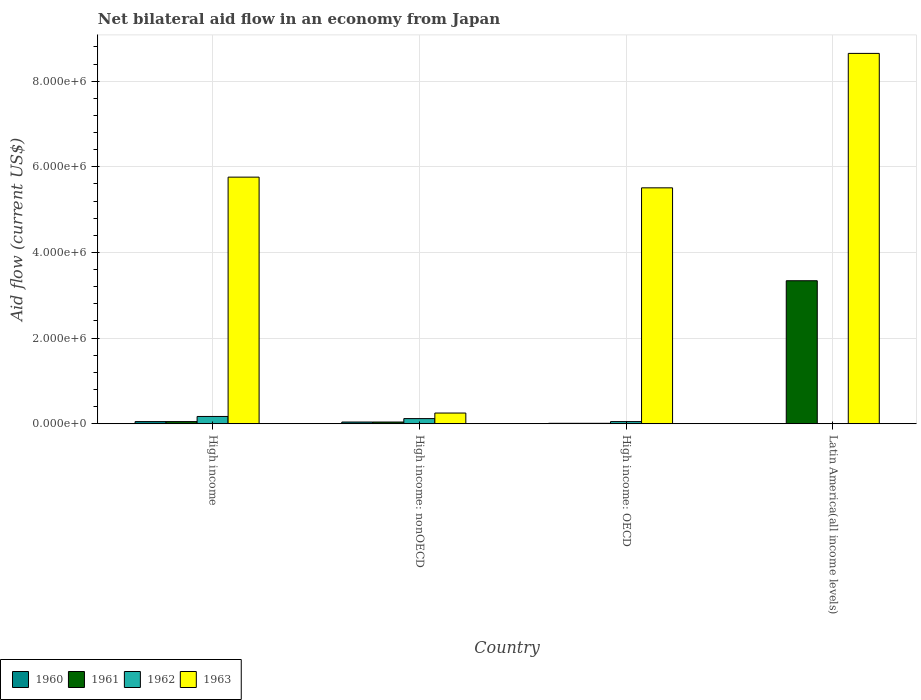How many different coloured bars are there?
Your response must be concise. 4. How many groups of bars are there?
Give a very brief answer. 4. How many bars are there on the 3rd tick from the right?
Make the answer very short. 4. What is the label of the 3rd group of bars from the left?
Give a very brief answer. High income: OECD. Across all countries, what is the maximum net bilateral aid flow in 1963?
Make the answer very short. 8.65e+06. Across all countries, what is the minimum net bilateral aid flow in 1963?
Your answer should be compact. 2.50e+05. In which country was the net bilateral aid flow in 1960 maximum?
Your answer should be compact. High income. What is the difference between the net bilateral aid flow in 1961 in High income: OECD and that in High income: nonOECD?
Provide a short and direct response. -3.00e+04. What is the difference between the net bilateral aid flow in 1963 in High income and the net bilateral aid flow in 1961 in Latin America(all income levels)?
Give a very brief answer. 2.42e+06. What is the average net bilateral aid flow in 1961 per country?
Offer a terse response. 8.60e+05. In how many countries, is the net bilateral aid flow in 1961 greater than 2800000 US$?
Offer a terse response. 1. What is the ratio of the net bilateral aid flow in 1960 in High income to that in High income: nonOECD?
Your answer should be very brief. 1.25. What is the difference between the highest and the second highest net bilateral aid flow in 1963?
Your answer should be compact. 2.89e+06. Is it the case that in every country, the sum of the net bilateral aid flow in 1961 and net bilateral aid flow in 1963 is greater than the net bilateral aid flow in 1960?
Provide a short and direct response. Yes. How many bars are there?
Your response must be concise. 14. What is the difference between two consecutive major ticks on the Y-axis?
Provide a succinct answer. 2.00e+06. Does the graph contain grids?
Offer a terse response. Yes. How are the legend labels stacked?
Provide a succinct answer. Horizontal. What is the title of the graph?
Give a very brief answer. Net bilateral aid flow in an economy from Japan. What is the Aid flow (current US$) in 1961 in High income?
Ensure brevity in your answer.  5.00e+04. What is the Aid flow (current US$) of 1963 in High income?
Offer a very short reply. 5.76e+06. What is the Aid flow (current US$) of 1962 in High income: OECD?
Offer a terse response. 5.00e+04. What is the Aid flow (current US$) of 1963 in High income: OECD?
Make the answer very short. 5.51e+06. What is the Aid flow (current US$) of 1960 in Latin America(all income levels)?
Offer a terse response. 0. What is the Aid flow (current US$) of 1961 in Latin America(all income levels)?
Keep it short and to the point. 3.34e+06. What is the Aid flow (current US$) of 1963 in Latin America(all income levels)?
Your response must be concise. 8.65e+06. Across all countries, what is the maximum Aid flow (current US$) of 1961?
Ensure brevity in your answer.  3.34e+06. Across all countries, what is the maximum Aid flow (current US$) of 1963?
Your answer should be compact. 8.65e+06. Across all countries, what is the minimum Aid flow (current US$) in 1961?
Provide a short and direct response. 10000. Across all countries, what is the minimum Aid flow (current US$) in 1962?
Your response must be concise. 0. What is the total Aid flow (current US$) in 1960 in the graph?
Offer a very short reply. 1.00e+05. What is the total Aid flow (current US$) in 1961 in the graph?
Provide a short and direct response. 3.44e+06. What is the total Aid flow (current US$) of 1963 in the graph?
Offer a terse response. 2.02e+07. What is the difference between the Aid flow (current US$) of 1963 in High income and that in High income: nonOECD?
Offer a terse response. 5.51e+06. What is the difference between the Aid flow (current US$) in 1962 in High income and that in High income: OECD?
Provide a succinct answer. 1.20e+05. What is the difference between the Aid flow (current US$) in 1961 in High income and that in Latin America(all income levels)?
Keep it short and to the point. -3.29e+06. What is the difference between the Aid flow (current US$) of 1963 in High income and that in Latin America(all income levels)?
Your answer should be compact. -2.89e+06. What is the difference between the Aid flow (current US$) in 1961 in High income: nonOECD and that in High income: OECD?
Ensure brevity in your answer.  3.00e+04. What is the difference between the Aid flow (current US$) of 1962 in High income: nonOECD and that in High income: OECD?
Offer a very short reply. 7.00e+04. What is the difference between the Aid flow (current US$) in 1963 in High income: nonOECD and that in High income: OECD?
Make the answer very short. -5.26e+06. What is the difference between the Aid flow (current US$) in 1961 in High income: nonOECD and that in Latin America(all income levels)?
Offer a terse response. -3.30e+06. What is the difference between the Aid flow (current US$) of 1963 in High income: nonOECD and that in Latin America(all income levels)?
Your answer should be compact. -8.40e+06. What is the difference between the Aid flow (current US$) of 1961 in High income: OECD and that in Latin America(all income levels)?
Make the answer very short. -3.33e+06. What is the difference between the Aid flow (current US$) in 1963 in High income: OECD and that in Latin America(all income levels)?
Offer a very short reply. -3.14e+06. What is the difference between the Aid flow (current US$) in 1960 in High income and the Aid flow (current US$) in 1961 in High income: nonOECD?
Provide a succinct answer. 10000. What is the difference between the Aid flow (current US$) of 1962 in High income and the Aid flow (current US$) of 1963 in High income: nonOECD?
Your answer should be very brief. -8.00e+04. What is the difference between the Aid flow (current US$) in 1960 in High income and the Aid flow (current US$) in 1962 in High income: OECD?
Offer a terse response. 0. What is the difference between the Aid flow (current US$) of 1960 in High income and the Aid flow (current US$) of 1963 in High income: OECD?
Your response must be concise. -5.46e+06. What is the difference between the Aid flow (current US$) in 1961 in High income and the Aid flow (current US$) in 1962 in High income: OECD?
Your answer should be compact. 0. What is the difference between the Aid flow (current US$) of 1961 in High income and the Aid flow (current US$) of 1963 in High income: OECD?
Your response must be concise. -5.46e+06. What is the difference between the Aid flow (current US$) of 1962 in High income and the Aid flow (current US$) of 1963 in High income: OECD?
Offer a very short reply. -5.34e+06. What is the difference between the Aid flow (current US$) of 1960 in High income and the Aid flow (current US$) of 1961 in Latin America(all income levels)?
Provide a short and direct response. -3.29e+06. What is the difference between the Aid flow (current US$) of 1960 in High income and the Aid flow (current US$) of 1963 in Latin America(all income levels)?
Your answer should be compact. -8.60e+06. What is the difference between the Aid flow (current US$) of 1961 in High income and the Aid flow (current US$) of 1963 in Latin America(all income levels)?
Give a very brief answer. -8.60e+06. What is the difference between the Aid flow (current US$) in 1962 in High income and the Aid flow (current US$) in 1963 in Latin America(all income levels)?
Offer a very short reply. -8.48e+06. What is the difference between the Aid flow (current US$) in 1960 in High income: nonOECD and the Aid flow (current US$) in 1961 in High income: OECD?
Your answer should be very brief. 3.00e+04. What is the difference between the Aid flow (current US$) of 1960 in High income: nonOECD and the Aid flow (current US$) of 1963 in High income: OECD?
Provide a short and direct response. -5.47e+06. What is the difference between the Aid flow (current US$) of 1961 in High income: nonOECD and the Aid flow (current US$) of 1963 in High income: OECD?
Offer a very short reply. -5.47e+06. What is the difference between the Aid flow (current US$) of 1962 in High income: nonOECD and the Aid flow (current US$) of 1963 in High income: OECD?
Offer a terse response. -5.39e+06. What is the difference between the Aid flow (current US$) in 1960 in High income: nonOECD and the Aid flow (current US$) in 1961 in Latin America(all income levels)?
Your answer should be compact. -3.30e+06. What is the difference between the Aid flow (current US$) in 1960 in High income: nonOECD and the Aid flow (current US$) in 1963 in Latin America(all income levels)?
Ensure brevity in your answer.  -8.61e+06. What is the difference between the Aid flow (current US$) of 1961 in High income: nonOECD and the Aid flow (current US$) of 1963 in Latin America(all income levels)?
Keep it short and to the point. -8.61e+06. What is the difference between the Aid flow (current US$) in 1962 in High income: nonOECD and the Aid flow (current US$) in 1963 in Latin America(all income levels)?
Your answer should be very brief. -8.53e+06. What is the difference between the Aid flow (current US$) in 1960 in High income: OECD and the Aid flow (current US$) in 1961 in Latin America(all income levels)?
Keep it short and to the point. -3.33e+06. What is the difference between the Aid flow (current US$) of 1960 in High income: OECD and the Aid flow (current US$) of 1963 in Latin America(all income levels)?
Provide a short and direct response. -8.64e+06. What is the difference between the Aid flow (current US$) of 1961 in High income: OECD and the Aid flow (current US$) of 1963 in Latin America(all income levels)?
Provide a short and direct response. -8.64e+06. What is the difference between the Aid flow (current US$) of 1962 in High income: OECD and the Aid flow (current US$) of 1963 in Latin America(all income levels)?
Ensure brevity in your answer.  -8.60e+06. What is the average Aid flow (current US$) in 1960 per country?
Provide a short and direct response. 2.50e+04. What is the average Aid flow (current US$) in 1961 per country?
Provide a succinct answer. 8.60e+05. What is the average Aid flow (current US$) of 1962 per country?
Provide a succinct answer. 8.50e+04. What is the average Aid flow (current US$) in 1963 per country?
Ensure brevity in your answer.  5.04e+06. What is the difference between the Aid flow (current US$) of 1960 and Aid flow (current US$) of 1961 in High income?
Your answer should be very brief. 0. What is the difference between the Aid flow (current US$) in 1960 and Aid flow (current US$) in 1962 in High income?
Provide a short and direct response. -1.20e+05. What is the difference between the Aid flow (current US$) of 1960 and Aid flow (current US$) of 1963 in High income?
Make the answer very short. -5.71e+06. What is the difference between the Aid flow (current US$) in 1961 and Aid flow (current US$) in 1963 in High income?
Ensure brevity in your answer.  -5.71e+06. What is the difference between the Aid flow (current US$) of 1962 and Aid flow (current US$) of 1963 in High income?
Your answer should be very brief. -5.59e+06. What is the difference between the Aid flow (current US$) of 1960 and Aid flow (current US$) of 1961 in High income: nonOECD?
Give a very brief answer. 0. What is the difference between the Aid flow (current US$) in 1960 and Aid flow (current US$) in 1962 in High income: nonOECD?
Provide a short and direct response. -8.00e+04. What is the difference between the Aid flow (current US$) in 1961 and Aid flow (current US$) in 1962 in High income: nonOECD?
Your response must be concise. -8.00e+04. What is the difference between the Aid flow (current US$) of 1962 and Aid flow (current US$) of 1963 in High income: nonOECD?
Keep it short and to the point. -1.30e+05. What is the difference between the Aid flow (current US$) of 1960 and Aid flow (current US$) of 1962 in High income: OECD?
Provide a short and direct response. -4.00e+04. What is the difference between the Aid flow (current US$) of 1960 and Aid flow (current US$) of 1963 in High income: OECD?
Your response must be concise. -5.50e+06. What is the difference between the Aid flow (current US$) of 1961 and Aid flow (current US$) of 1963 in High income: OECD?
Your answer should be very brief. -5.50e+06. What is the difference between the Aid flow (current US$) of 1962 and Aid flow (current US$) of 1963 in High income: OECD?
Make the answer very short. -5.46e+06. What is the difference between the Aid flow (current US$) in 1961 and Aid flow (current US$) in 1963 in Latin America(all income levels)?
Make the answer very short. -5.31e+06. What is the ratio of the Aid flow (current US$) of 1960 in High income to that in High income: nonOECD?
Your answer should be very brief. 1.25. What is the ratio of the Aid flow (current US$) in 1961 in High income to that in High income: nonOECD?
Ensure brevity in your answer.  1.25. What is the ratio of the Aid flow (current US$) of 1962 in High income to that in High income: nonOECD?
Your response must be concise. 1.42. What is the ratio of the Aid flow (current US$) in 1963 in High income to that in High income: nonOECD?
Keep it short and to the point. 23.04. What is the ratio of the Aid flow (current US$) in 1960 in High income to that in High income: OECD?
Your answer should be very brief. 5. What is the ratio of the Aid flow (current US$) of 1963 in High income to that in High income: OECD?
Give a very brief answer. 1.05. What is the ratio of the Aid flow (current US$) in 1961 in High income to that in Latin America(all income levels)?
Keep it short and to the point. 0.01. What is the ratio of the Aid flow (current US$) in 1963 in High income to that in Latin America(all income levels)?
Offer a terse response. 0.67. What is the ratio of the Aid flow (current US$) in 1963 in High income: nonOECD to that in High income: OECD?
Provide a succinct answer. 0.05. What is the ratio of the Aid flow (current US$) in 1961 in High income: nonOECD to that in Latin America(all income levels)?
Offer a terse response. 0.01. What is the ratio of the Aid flow (current US$) in 1963 in High income: nonOECD to that in Latin America(all income levels)?
Give a very brief answer. 0.03. What is the ratio of the Aid flow (current US$) in 1961 in High income: OECD to that in Latin America(all income levels)?
Give a very brief answer. 0. What is the ratio of the Aid flow (current US$) of 1963 in High income: OECD to that in Latin America(all income levels)?
Provide a short and direct response. 0.64. What is the difference between the highest and the second highest Aid flow (current US$) of 1960?
Provide a succinct answer. 10000. What is the difference between the highest and the second highest Aid flow (current US$) of 1961?
Provide a succinct answer. 3.29e+06. What is the difference between the highest and the second highest Aid flow (current US$) in 1962?
Your response must be concise. 5.00e+04. What is the difference between the highest and the second highest Aid flow (current US$) in 1963?
Your answer should be very brief. 2.89e+06. What is the difference between the highest and the lowest Aid flow (current US$) of 1961?
Your answer should be compact. 3.33e+06. What is the difference between the highest and the lowest Aid flow (current US$) of 1963?
Ensure brevity in your answer.  8.40e+06. 